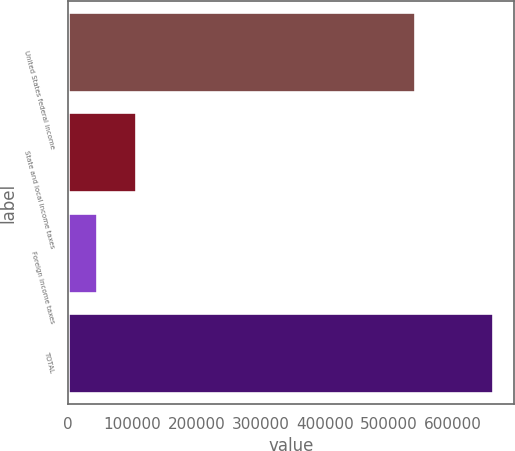<chart> <loc_0><loc_0><loc_500><loc_500><bar_chart><fcel>United States federal income<fcel>State and local income taxes<fcel>Foreign income taxes<fcel>TOTAL<nl><fcel>540861<fcel>106284<fcel>44492<fcel>662417<nl></chart> 